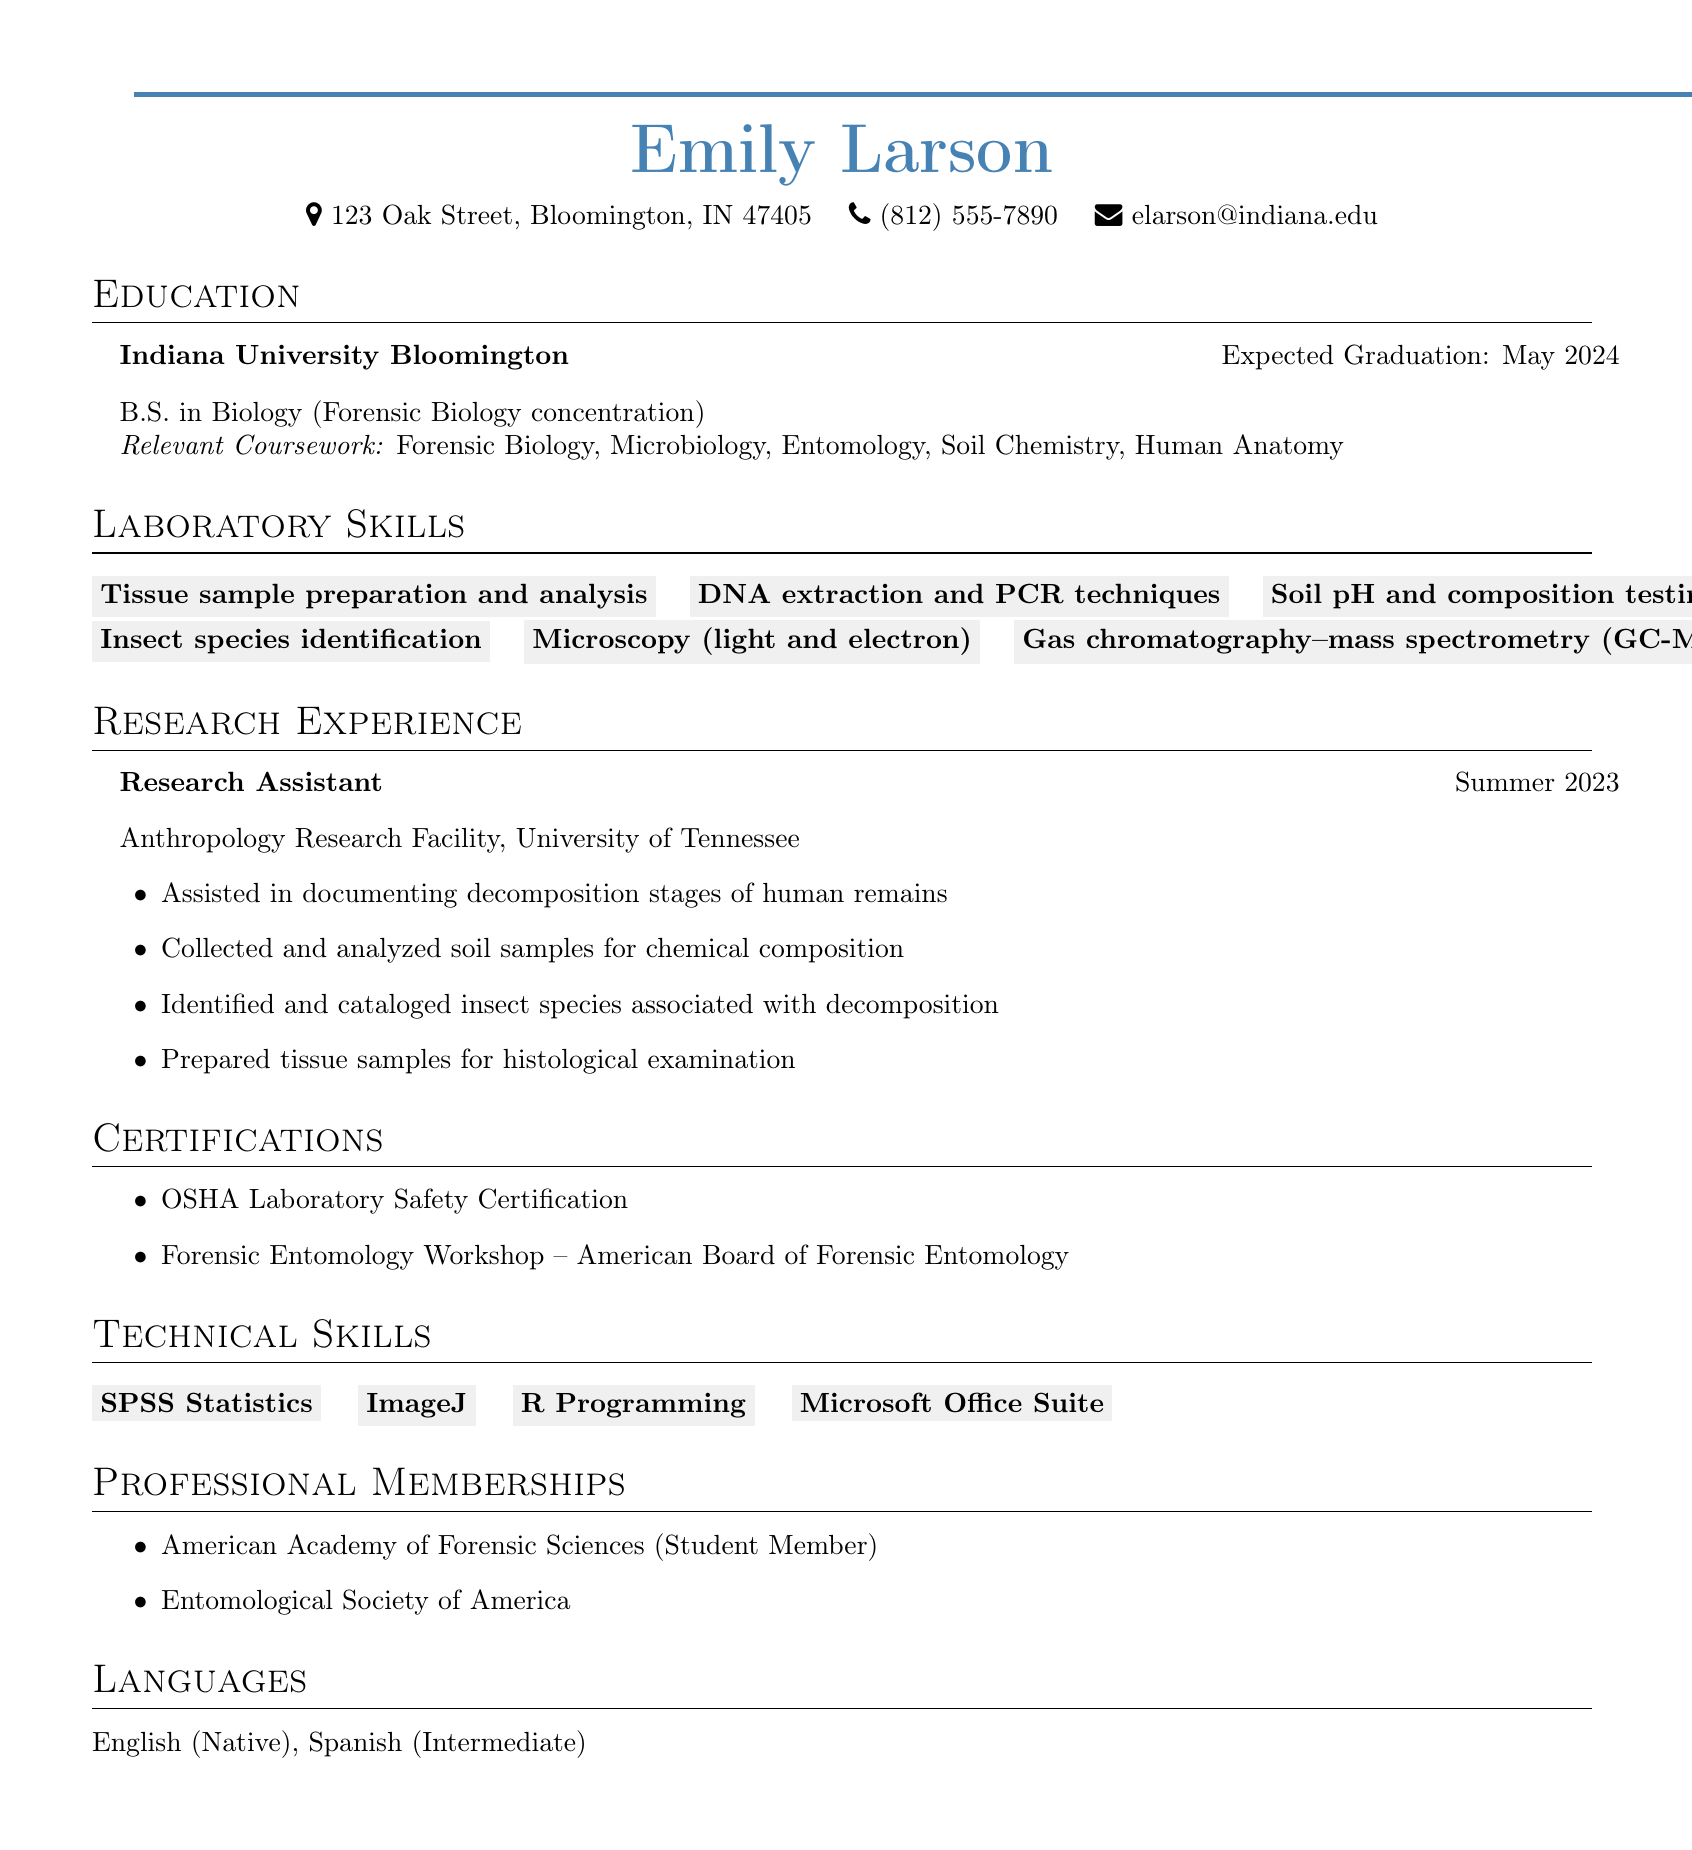what degree is Emily Larson pursuing? Emily Larson is pursuing a Bachelor of Science degree in Biology with a concentration in Forensic Biology as stated in the education section.
Answer: B.S. in Biology (Forensic Biology concentration) where did Emily Larson work as a Research Assistant? Emily Larson worked as a Research Assistant at the Anthropology Research Facility, University of Tennessee, which is detailed in the research experience section.
Answer: Anthropology Research Facility, University of Tennessee what is one of the laboratory skills Emily Larson has? One of the laboratory skills listed is tissue sample preparation and analysis, found in the laboratory skills section.
Answer: Tissue sample preparation and analysis when is Emily Larson expected to graduate? The document mentions that Emily Larson is expected to graduate in May 2024, which is specified in the education section.
Answer: May 2024 which certification does Emily Larson have related to safety? The document states that Emily Larson has an OSHA Laboratory Safety Certification, found in the certifications section.
Answer: OSHA Laboratory Safety Certification how many relevant coursework subjects are listed? There are five relevant coursework subjects listed in the education section: Forensic Biology, Microbiology, Entomology, Soil Chemistry, Human Anatomy.
Answer: 5 which society is Emily Larson a student member of? Emily Larson is a Student Member of the American Academy of Forensic Sciences, which is noted in the professional memberships section.
Answer: American Academy of Forensic Sciences what programming language skill does Emily Larson possess? The document specifies that Emily Larson has R Programming listed under her technical skills.
Answer: R Programming what type of analysis has Emily Larson conducted related to soil? The document indicates that she has performed soil pH and composition testing as listed in the laboratory skills section.
Answer: Soil pH and composition testing 